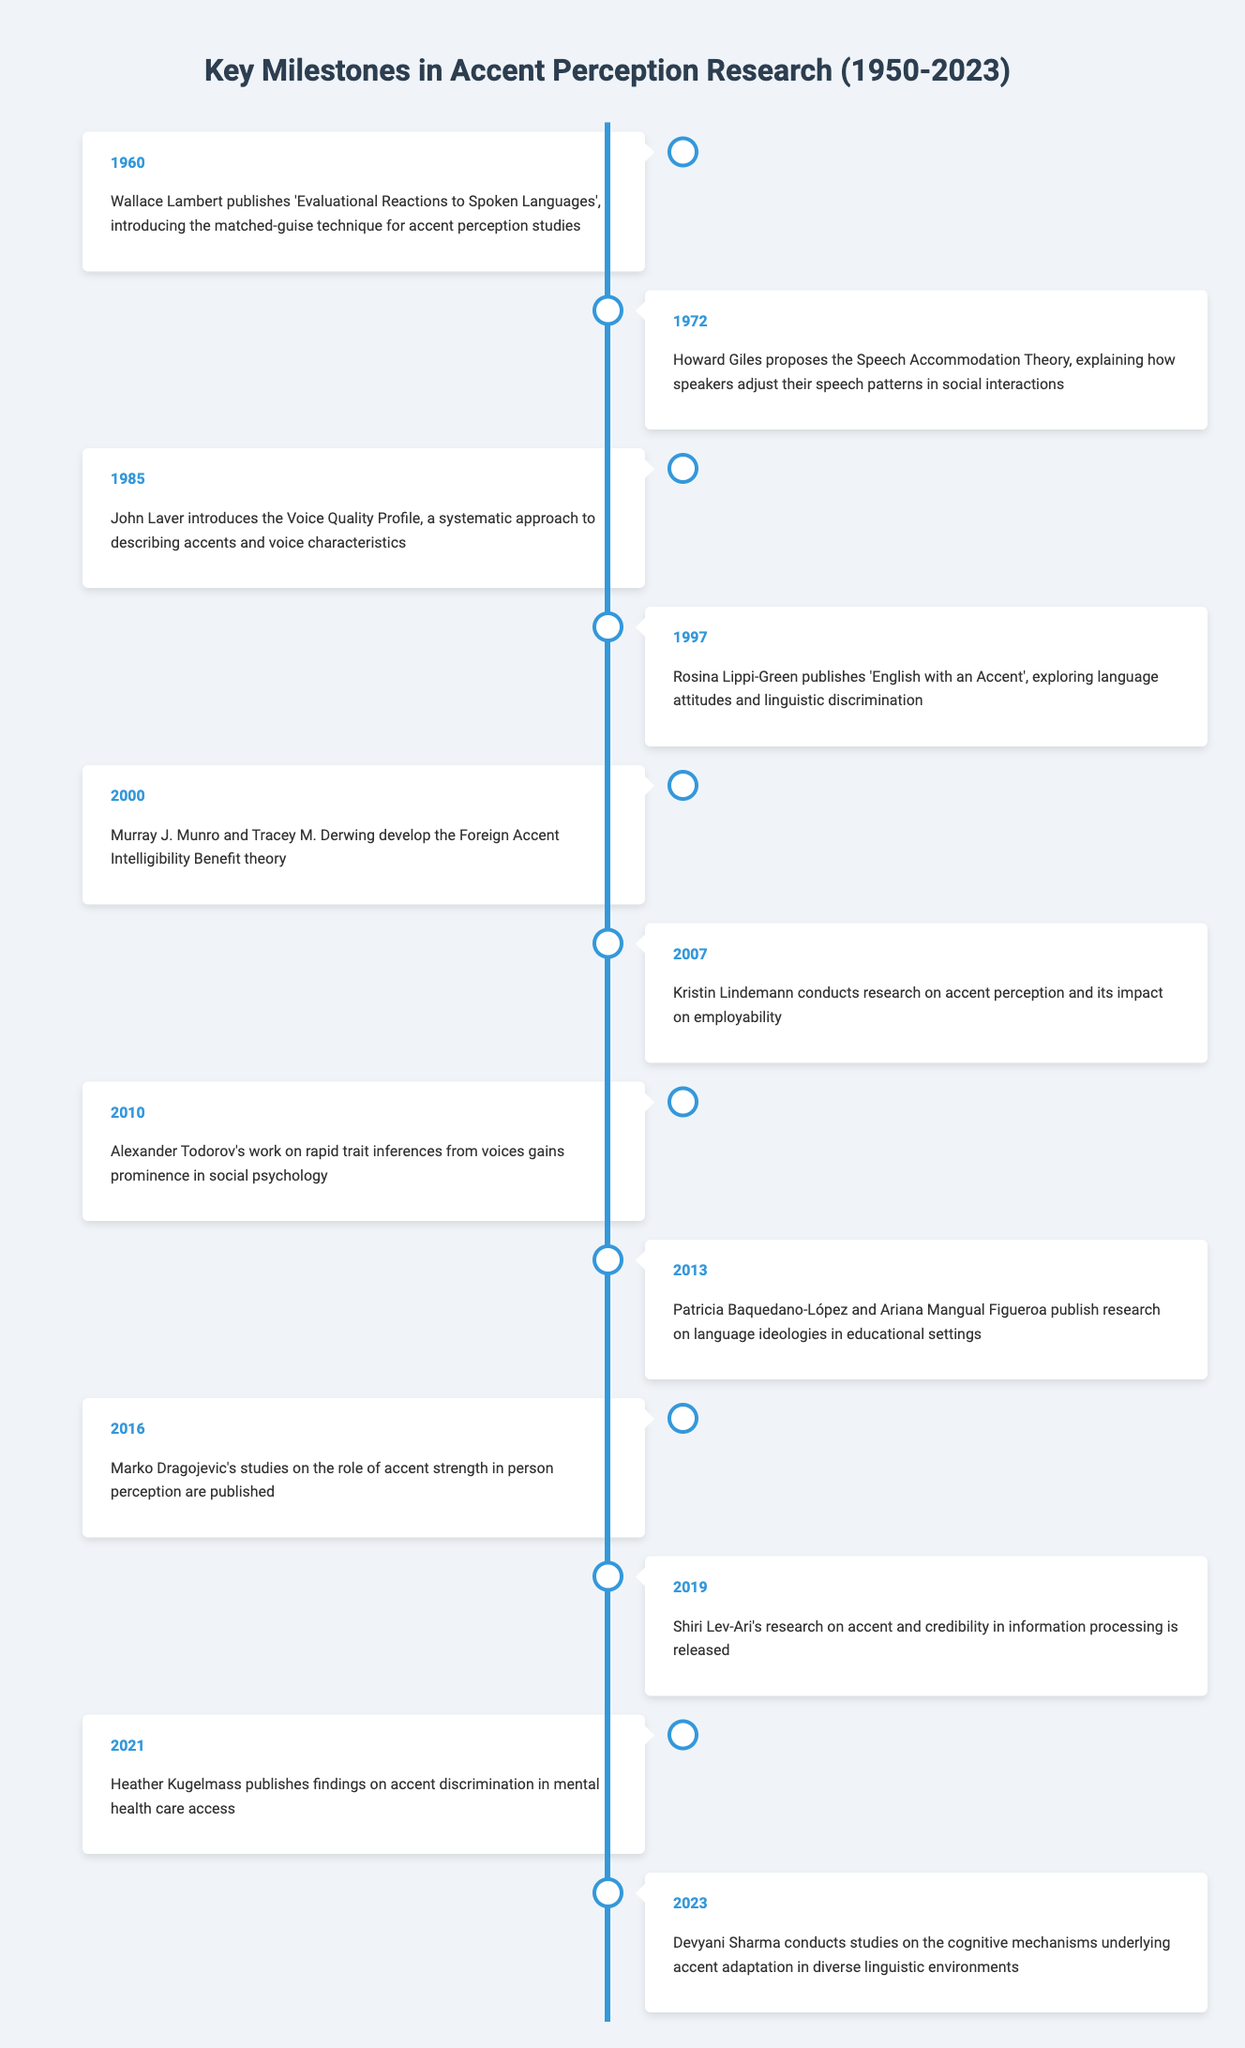What year did Wallace Lambert publish his work on accent perception? According to the timeline, Wallace Lambert published 'Evaluational Reactions to Spoken Languages' in 1960.
Answer: 1960 What major theory was proposed by Howard Giles in 1972? The timeline indicates that Howard Giles proposed the Speech Accommodation Theory in 1972, which explains how speakers adjust their speech patterns in social interactions.
Answer: Speech Accommodation Theory How many milestones are listed between 2000 and 2021? The milestones listed are from 2000 (Murray J. Munro and Tracey M. Derwing's theory) to 2021 (Heather Kugelmass's findings). Counting those milestones gives us 3: 2000, 2007, and 2021.
Answer: 3 True or False: The research conducted by Kristin Lindemann had a focus on educational settings. The timeline states that Kristin Lindemann's research conducted in 2007 focused on the impact of accent perception on employability, not educational settings. Therefore, this statement is false.
Answer: False Which event in the timeline discusses accent strength and its perception? The event discussing accent strength is from 2016, which mentions Marko Dragojevic's studies on the role of accent strength in person perception.
Answer: 2016 What is the difference in years between John Laver's introduction of the Voice Quality Profile and the publication of 'English with an Accent' by Rosina Lippi-Green? John Laver introduced the Voice Quality Profile in 1985 and 'English with an Accent' was published in 1997, giving a difference of 12 years when 1997 is subtracted from 1985.
Answer: 12 years In which year did research on accent and credibility in information processing occur? Shiri Lev-Ari’s research, which focuses on accent and credibility in information processing, is noted to be released in 2019 according to the timeline.
Answer: 2019 How many years passed between the publication of research on accent discrimination in mental health care access and the studies on cognitive mechanisms underlying accent adaptation? Research on accent discrimination was published in 2021 and studies on accent adaptation were conducted in 2023. Subtracting the two years shows that 2 years passed between these milestones.
Answer: 2 years True or False: The matched-guise technique was introduced after 1980. The matched-guise technique was introduced by Wallace Lambert in 1960, which is before 1980, making the statement false.
Answer: False 